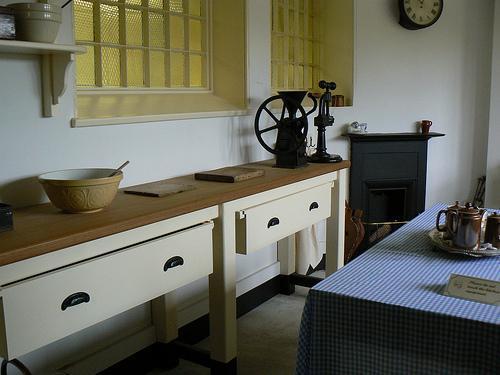How many cutting boards on the counters?
Give a very brief answer. 2. How many bowls are in this room?
Give a very brief answer. 3. How many drawers are shown?
Give a very brief answer. 2. How many windows are in the picture?
Give a very brief answer. 2. How many drawers are in the picture?
Give a very brief answer. 2. How many clocks are on the wall?
Give a very brief answer. 1. 